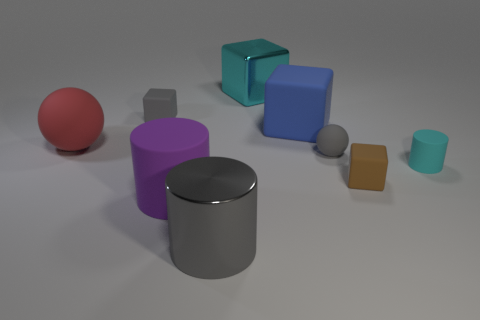Subtract 1 blocks. How many blocks are left? 3 Subtract all balls. How many objects are left? 7 Subtract 0 red cylinders. How many objects are left? 9 Subtract all big gray cylinders. Subtract all big blocks. How many objects are left? 6 Add 7 big purple things. How many big purple things are left? 8 Add 5 purple things. How many purple things exist? 6 